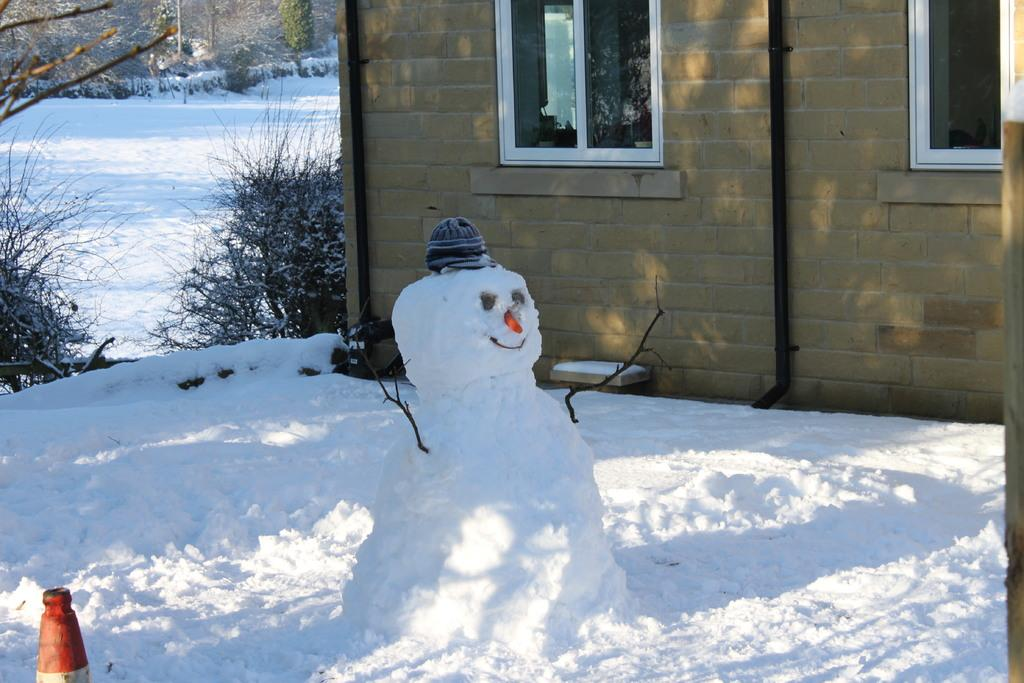What type of toy can be seen in the image? There is a snow toy in the image. What other object is present in the image? There is a traffic cone in the image. Can you describe the house in the image? The house has windows in the image. What is the weather like in the image? There is snow visible in the image, indicating a snowy environment. What can be seen in the background of the image? There are trees in the background of the image. Can you tell me how many airplanes are flying over the house in the image? There are no airplanes visible in the image; it only shows a snow toy, a traffic cone, a house with windows, snow, and trees in the background. What type of beam is supporting the house in the image? There is no beam visible in the image; the house is supported by its foundation and walls. 